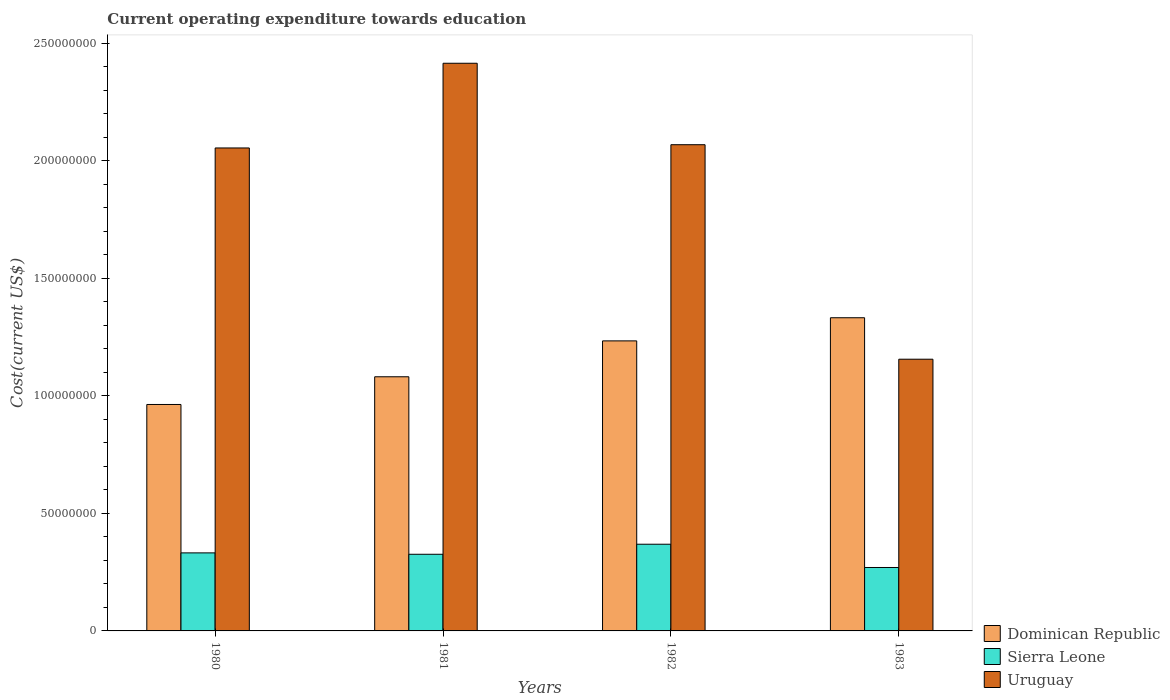How many groups of bars are there?
Your answer should be very brief. 4. Are the number of bars per tick equal to the number of legend labels?
Make the answer very short. Yes. Are the number of bars on each tick of the X-axis equal?
Offer a terse response. Yes. How many bars are there on the 4th tick from the left?
Offer a very short reply. 3. How many bars are there on the 1st tick from the right?
Offer a terse response. 3. What is the label of the 4th group of bars from the left?
Provide a succinct answer. 1983. What is the expenditure towards education in Dominican Republic in 1981?
Your response must be concise. 1.08e+08. Across all years, what is the maximum expenditure towards education in Dominican Republic?
Your answer should be compact. 1.33e+08. Across all years, what is the minimum expenditure towards education in Sierra Leone?
Offer a very short reply. 2.70e+07. In which year was the expenditure towards education in Uruguay maximum?
Offer a very short reply. 1981. In which year was the expenditure towards education in Uruguay minimum?
Give a very brief answer. 1983. What is the total expenditure towards education in Uruguay in the graph?
Provide a short and direct response. 7.69e+08. What is the difference between the expenditure towards education in Sierra Leone in 1981 and that in 1983?
Offer a terse response. 5.62e+06. What is the difference between the expenditure towards education in Dominican Republic in 1981 and the expenditure towards education in Sierra Leone in 1983?
Ensure brevity in your answer.  8.11e+07. What is the average expenditure towards education in Sierra Leone per year?
Your response must be concise. 3.24e+07. In the year 1983, what is the difference between the expenditure towards education in Sierra Leone and expenditure towards education in Uruguay?
Your response must be concise. -8.86e+07. In how many years, is the expenditure towards education in Dominican Republic greater than 60000000 US$?
Your answer should be compact. 4. What is the ratio of the expenditure towards education in Dominican Republic in 1980 to that in 1982?
Your response must be concise. 0.78. Is the expenditure towards education in Sierra Leone in 1981 less than that in 1983?
Provide a succinct answer. No. What is the difference between the highest and the second highest expenditure towards education in Dominican Republic?
Give a very brief answer. 9.84e+06. What is the difference between the highest and the lowest expenditure towards education in Dominican Republic?
Your answer should be very brief. 3.69e+07. What does the 2nd bar from the left in 1981 represents?
Offer a terse response. Sierra Leone. What does the 1st bar from the right in 1983 represents?
Your response must be concise. Uruguay. Is it the case that in every year, the sum of the expenditure towards education in Dominican Republic and expenditure towards education in Sierra Leone is greater than the expenditure towards education in Uruguay?
Your answer should be very brief. No. How many bars are there?
Your answer should be compact. 12. Are all the bars in the graph horizontal?
Make the answer very short. No. What is the difference between two consecutive major ticks on the Y-axis?
Keep it short and to the point. 5.00e+07. Are the values on the major ticks of Y-axis written in scientific E-notation?
Make the answer very short. No. Does the graph contain any zero values?
Give a very brief answer. No. Does the graph contain grids?
Offer a very short reply. No. Where does the legend appear in the graph?
Your answer should be very brief. Bottom right. How many legend labels are there?
Offer a terse response. 3. What is the title of the graph?
Your answer should be compact. Current operating expenditure towards education. What is the label or title of the Y-axis?
Offer a terse response. Cost(current US$). What is the Cost(current US$) in Dominican Republic in 1980?
Offer a terse response. 9.63e+07. What is the Cost(current US$) in Sierra Leone in 1980?
Your response must be concise. 3.32e+07. What is the Cost(current US$) of Uruguay in 1980?
Ensure brevity in your answer.  2.05e+08. What is the Cost(current US$) of Dominican Republic in 1981?
Provide a succinct answer. 1.08e+08. What is the Cost(current US$) of Sierra Leone in 1981?
Provide a short and direct response. 3.26e+07. What is the Cost(current US$) of Uruguay in 1981?
Your response must be concise. 2.41e+08. What is the Cost(current US$) of Dominican Republic in 1982?
Keep it short and to the point. 1.23e+08. What is the Cost(current US$) in Sierra Leone in 1982?
Your answer should be very brief. 3.69e+07. What is the Cost(current US$) of Uruguay in 1982?
Give a very brief answer. 2.07e+08. What is the Cost(current US$) of Dominican Republic in 1983?
Your answer should be compact. 1.33e+08. What is the Cost(current US$) of Sierra Leone in 1983?
Make the answer very short. 2.70e+07. What is the Cost(current US$) of Uruguay in 1983?
Provide a succinct answer. 1.16e+08. Across all years, what is the maximum Cost(current US$) in Dominican Republic?
Provide a short and direct response. 1.33e+08. Across all years, what is the maximum Cost(current US$) in Sierra Leone?
Give a very brief answer. 3.69e+07. Across all years, what is the maximum Cost(current US$) of Uruguay?
Offer a terse response. 2.41e+08. Across all years, what is the minimum Cost(current US$) of Dominican Republic?
Ensure brevity in your answer.  9.63e+07. Across all years, what is the minimum Cost(current US$) in Sierra Leone?
Provide a succinct answer. 2.70e+07. Across all years, what is the minimum Cost(current US$) of Uruguay?
Offer a terse response. 1.16e+08. What is the total Cost(current US$) in Dominican Republic in the graph?
Offer a very short reply. 4.61e+08. What is the total Cost(current US$) of Sierra Leone in the graph?
Provide a succinct answer. 1.30e+08. What is the total Cost(current US$) in Uruguay in the graph?
Ensure brevity in your answer.  7.69e+08. What is the difference between the Cost(current US$) of Dominican Republic in 1980 and that in 1981?
Your answer should be very brief. -1.18e+07. What is the difference between the Cost(current US$) of Sierra Leone in 1980 and that in 1981?
Ensure brevity in your answer.  5.90e+05. What is the difference between the Cost(current US$) of Uruguay in 1980 and that in 1981?
Ensure brevity in your answer.  -3.60e+07. What is the difference between the Cost(current US$) of Dominican Republic in 1980 and that in 1982?
Provide a short and direct response. -2.71e+07. What is the difference between the Cost(current US$) in Sierra Leone in 1980 and that in 1982?
Give a very brief answer. -3.69e+06. What is the difference between the Cost(current US$) of Uruguay in 1980 and that in 1982?
Provide a short and direct response. -1.38e+06. What is the difference between the Cost(current US$) in Dominican Republic in 1980 and that in 1983?
Offer a terse response. -3.69e+07. What is the difference between the Cost(current US$) of Sierra Leone in 1980 and that in 1983?
Offer a very short reply. 6.21e+06. What is the difference between the Cost(current US$) in Uruguay in 1980 and that in 1983?
Provide a succinct answer. 8.99e+07. What is the difference between the Cost(current US$) of Dominican Republic in 1981 and that in 1982?
Your answer should be very brief. -1.53e+07. What is the difference between the Cost(current US$) of Sierra Leone in 1981 and that in 1982?
Provide a succinct answer. -4.28e+06. What is the difference between the Cost(current US$) of Uruguay in 1981 and that in 1982?
Your answer should be compact. 3.46e+07. What is the difference between the Cost(current US$) of Dominican Republic in 1981 and that in 1983?
Offer a terse response. -2.51e+07. What is the difference between the Cost(current US$) in Sierra Leone in 1981 and that in 1983?
Your answer should be compact. 5.62e+06. What is the difference between the Cost(current US$) in Uruguay in 1981 and that in 1983?
Ensure brevity in your answer.  1.26e+08. What is the difference between the Cost(current US$) of Dominican Republic in 1982 and that in 1983?
Ensure brevity in your answer.  -9.84e+06. What is the difference between the Cost(current US$) of Sierra Leone in 1982 and that in 1983?
Provide a succinct answer. 9.90e+06. What is the difference between the Cost(current US$) in Uruguay in 1982 and that in 1983?
Give a very brief answer. 9.12e+07. What is the difference between the Cost(current US$) of Dominican Republic in 1980 and the Cost(current US$) of Sierra Leone in 1981?
Provide a succinct answer. 6.37e+07. What is the difference between the Cost(current US$) in Dominican Republic in 1980 and the Cost(current US$) in Uruguay in 1981?
Make the answer very short. -1.45e+08. What is the difference between the Cost(current US$) of Sierra Leone in 1980 and the Cost(current US$) of Uruguay in 1981?
Keep it short and to the point. -2.08e+08. What is the difference between the Cost(current US$) in Dominican Republic in 1980 and the Cost(current US$) in Sierra Leone in 1982?
Your answer should be compact. 5.94e+07. What is the difference between the Cost(current US$) in Dominican Republic in 1980 and the Cost(current US$) in Uruguay in 1982?
Your response must be concise. -1.10e+08. What is the difference between the Cost(current US$) of Sierra Leone in 1980 and the Cost(current US$) of Uruguay in 1982?
Provide a short and direct response. -1.74e+08. What is the difference between the Cost(current US$) in Dominican Republic in 1980 and the Cost(current US$) in Sierra Leone in 1983?
Your response must be concise. 6.93e+07. What is the difference between the Cost(current US$) of Dominican Republic in 1980 and the Cost(current US$) of Uruguay in 1983?
Your answer should be very brief. -1.93e+07. What is the difference between the Cost(current US$) in Sierra Leone in 1980 and the Cost(current US$) in Uruguay in 1983?
Your answer should be compact. -8.24e+07. What is the difference between the Cost(current US$) in Dominican Republic in 1981 and the Cost(current US$) in Sierra Leone in 1982?
Keep it short and to the point. 7.12e+07. What is the difference between the Cost(current US$) in Dominican Republic in 1981 and the Cost(current US$) in Uruguay in 1982?
Give a very brief answer. -9.87e+07. What is the difference between the Cost(current US$) in Sierra Leone in 1981 and the Cost(current US$) in Uruguay in 1982?
Give a very brief answer. -1.74e+08. What is the difference between the Cost(current US$) in Dominican Republic in 1981 and the Cost(current US$) in Sierra Leone in 1983?
Give a very brief answer. 8.11e+07. What is the difference between the Cost(current US$) in Dominican Republic in 1981 and the Cost(current US$) in Uruguay in 1983?
Your answer should be very brief. -7.47e+06. What is the difference between the Cost(current US$) of Sierra Leone in 1981 and the Cost(current US$) of Uruguay in 1983?
Give a very brief answer. -8.30e+07. What is the difference between the Cost(current US$) in Dominican Republic in 1982 and the Cost(current US$) in Sierra Leone in 1983?
Provide a succinct answer. 9.64e+07. What is the difference between the Cost(current US$) in Dominican Republic in 1982 and the Cost(current US$) in Uruguay in 1983?
Make the answer very short. 7.80e+06. What is the difference between the Cost(current US$) of Sierra Leone in 1982 and the Cost(current US$) of Uruguay in 1983?
Your answer should be compact. -7.87e+07. What is the average Cost(current US$) in Dominican Republic per year?
Your answer should be very brief. 1.15e+08. What is the average Cost(current US$) in Sierra Leone per year?
Offer a very short reply. 3.24e+07. What is the average Cost(current US$) in Uruguay per year?
Make the answer very short. 1.92e+08. In the year 1980, what is the difference between the Cost(current US$) in Dominican Republic and Cost(current US$) in Sierra Leone?
Provide a succinct answer. 6.31e+07. In the year 1980, what is the difference between the Cost(current US$) in Dominican Republic and Cost(current US$) in Uruguay?
Keep it short and to the point. -1.09e+08. In the year 1980, what is the difference between the Cost(current US$) in Sierra Leone and Cost(current US$) in Uruguay?
Your response must be concise. -1.72e+08. In the year 1981, what is the difference between the Cost(current US$) of Dominican Republic and Cost(current US$) of Sierra Leone?
Offer a terse response. 7.55e+07. In the year 1981, what is the difference between the Cost(current US$) of Dominican Republic and Cost(current US$) of Uruguay?
Keep it short and to the point. -1.33e+08. In the year 1981, what is the difference between the Cost(current US$) in Sierra Leone and Cost(current US$) in Uruguay?
Ensure brevity in your answer.  -2.09e+08. In the year 1982, what is the difference between the Cost(current US$) in Dominican Republic and Cost(current US$) in Sierra Leone?
Offer a very short reply. 8.65e+07. In the year 1982, what is the difference between the Cost(current US$) in Dominican Republic and Cost(current US$) in Uruguay?
Make the answer very short. -8.34e+07. In the year 1982, what is the difference between the Cost(current US$) in Sierra Leone and Cost(current US$) in Uruguay?
Ensure brevity in your answer.  -1.70e+08. In the year 1983, what is the difference between the Cost(current US$) of Dominican Republic and Cost(current US$) of Sierra Leone?
Your answer should be very brief. 1.06e+08. In the year 1983, what is the difference between the Cost(current US$) in Dominican Republic and Cost(current US$) in Uruguay?
Ensure brevity in your answer.  1.76e+07. In the year 1983, what is the difference between the Cost(current US$) of Sierra Leone and Cost(current US$) of Uruguay?
Ensure brevity in your answer.  -8.86e+07. What is the ratio of the Cost(current US$) in Dominican Republic in 1980 to that in 1981?
Your answer should be very brief. 0.89. What is the ratio of the Cost(current US$) in Sierra Leone in 1980 to that in 1981?
Provide a short and direct response. 1.02. What is the ratio of the Cost(current US$) in Uruguay in 1980 to that in 1981?
Your answer should be compact. 0.85. What is the ratio of the Cost(current US$) of Dominican Republic in 1980 to that in 1982?
Make the answer very short. 0.78. What is the ratio of the Cost(current US$) of Dominican Republic in 1980 to that in 1983?
Keep it short and to the point. 0.72. What is the ratio of the Cost(current US$) of Sierra Leone in 1980 to that in 1983?
Provide a succinct answer. 1.23. What is the ratio of the Cost(current US$) in Uruguay in 1980 to that in 1983?
Make the answer very short. 1.78. What is the ratio of the Cost(current US$) in Dominican Republic in 1981 to that in 1982?
Your answer should be very brief. 0.88. What is the ratio of the Cost(current US$) of Sierra Leone in 1981 to that in 1982?
Your answer should be very brief. 0.88. What is the ratio of the Cost(current US$) in Uruguay in 1981 to that in 1982?
Ensure brevity in your answer.  1.17. What is the ratio of the Cost(current US$) of Dominican Republic in 1981 to that in 1983?
Offer a terse response. 0.81. What is the ratio of the Cost(current US$) of Sierra Leone in 1981 to that in 1983?
Your answer should be compact. 1.21. What is the ratio of the Cost(current US$) of Uruguay in 1981 to that in 1983?
Provide a short and direct response. 2.09. What is the ratio of the Cost(current US$) of Dominican Republic in 1982 to that in 1983?
Provide a short and direct response. 0.93. What is the ratio of the Cost(current US$) in Sierra Leone in 1982 to that in 1983?
Your response must be concise. 1.37. What is the ratio of the Cost(current US$) of Uruguay in 1982 to that in 1983?
Your answer should be compact. 1.79. What is the difference between the highest and the second highest Cost(current US$) of Dominican Republic?
Your response must be concise. 9.84e+06. What is the difference between the highest and the second highest Cost(current US$) of Sierra Leone?
Offer a terse response. 3.69e+06. What is the difference between the highest and the second highest Cost(current US$) in Uruguay?
Keep it short and to the point. 3.46e+07. What is the difference between the highest and the lowest Cost(current US$) of Dominican Republic?
Offer a terse response. 3.69e+07. What is the difference between the highest and the lowest Cost(current US$) in Sierra Leone?
Your answer should be very brief. 9.90e+06. What is the difference between the highest and the lowest Cost(current US$) of Uruguay?
Ensure brevity in your answer.  1.26e+08. 